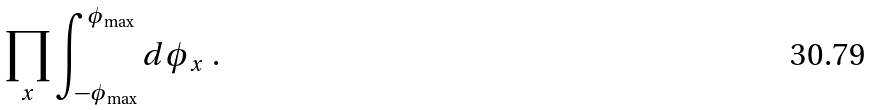Convert formula to latex. <formula><loc_0><loc_0><loc_500><loc_500>\prod _ { x } \int _ { - \phi _ { \max } } ^ { \phi _ { \max } } d \phi _ { x } \ .</formula> 